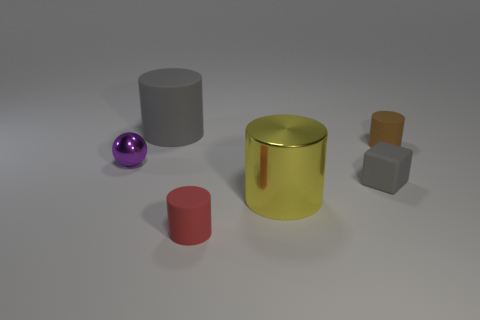Add 1 small purple objects. How many objects exist? 7 Subtract all cylinders. How many objects are left? 2 Add 4 big brown metal cylinders. How many big brown metal cylinders exist? 4 Subtract 0 blue spheres. How many objects are left? 6 Subtract all small gray rubber things. Subtract all metal balls. How many objects are left? 4 Add 4 gray blocks. How many gray blocks are left? 5 